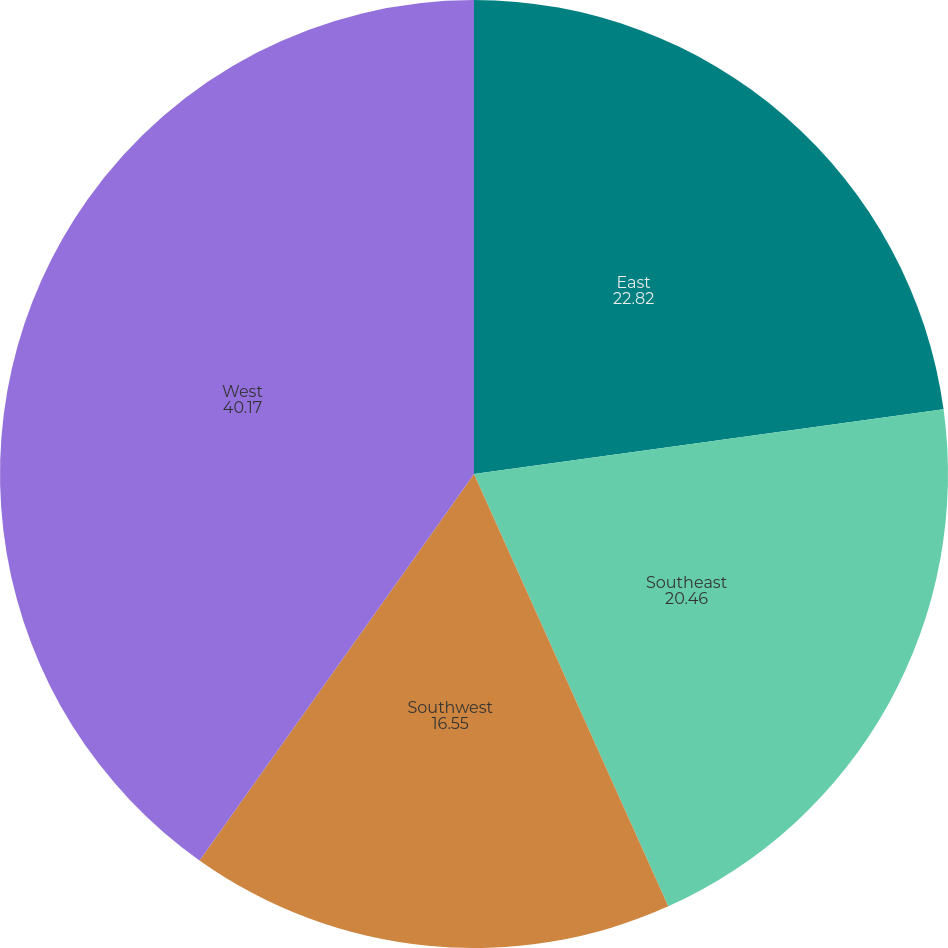Convert chart. <chart><loc_0><loc_0><loc_500><loc_500><pie_chart><fcel>East<fcel>Southeast<fcel>Southwest<fcel>West<nl><fcel>22.82%<fcel>20.46%<fcel>16.55%<fcel>40.17%<nl></chart> 